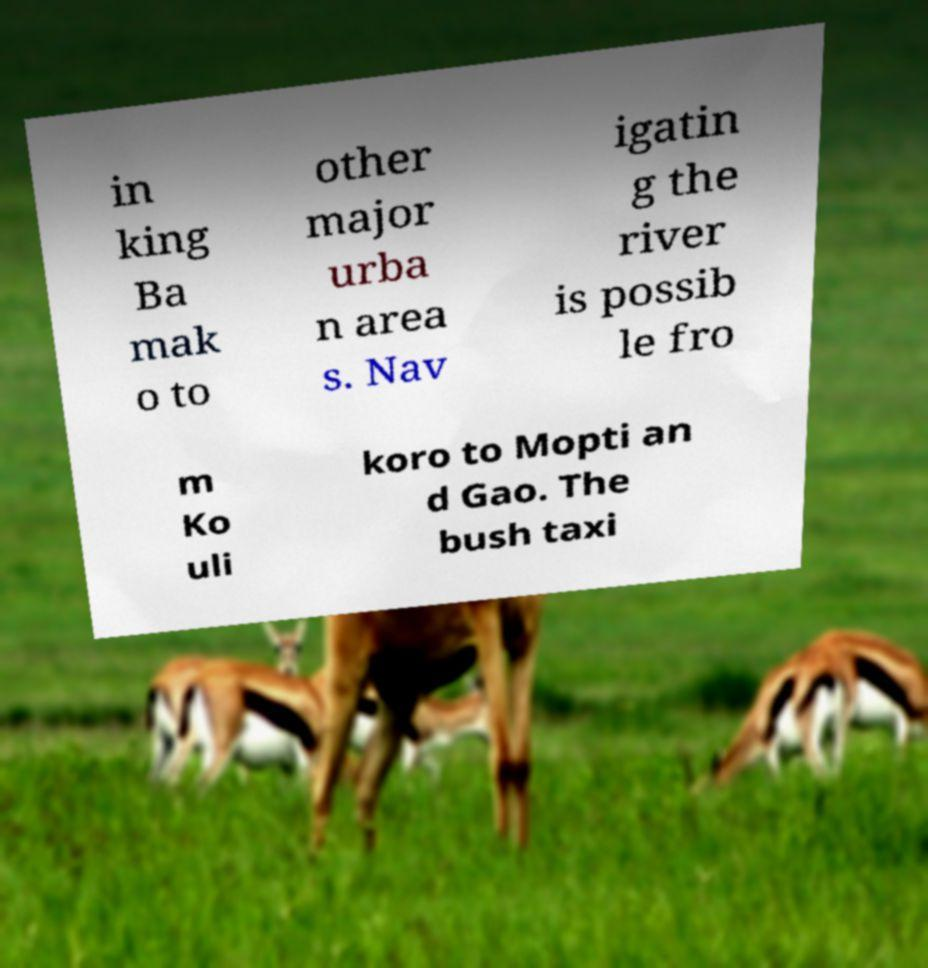I need the written content from this picture converted into text. Can you do that? in king Ba mak o to other major urba n area s. Nav igatin g the river is possib le fro m Ko uli koro to Mopti an d Gao. The bush taxi 